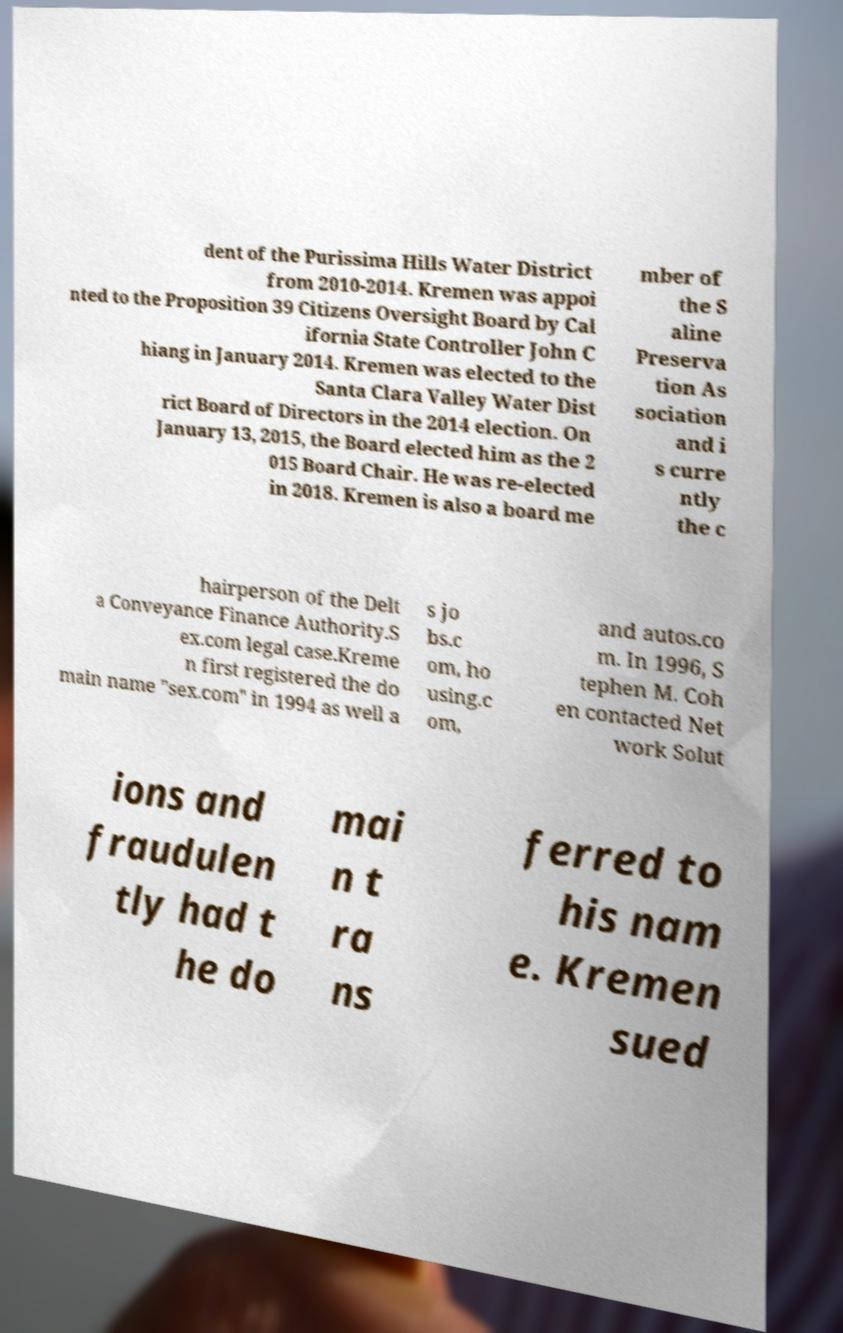There's text embedded in this image that I need extracted. Can you transcribe it verbatim? dent of the Purissima Hills Water District from 2010-2014. Kremen was appoi nted to the Proposition 39 Citizens Oversight Board by Cal ifornia State Controller John C hiang in January 2014. Kremen was elected to the Santa Clara Valley Water Dist rict Board of Directors in the 2014 election. On January 13, 2015, the Board elected him as the 2 015 Board Chair. He was re-elected in 2018. Kremen is also a board me mber of the S aline Preserva tion As sociation and i s curre ntly the c hairperson of the Delt a Conveyance Finance Authority.S ex.com legal case.Kreme n first registered the do main name "sex.com" in 1994 as well a s jo bs.c om, ho using.c om, and autos.co m. In 1996, S tephen M. Coh en contacted Net work Solut ions and fraudulen tly had t he do mai n t ra ns ferred to his nam e. Kremen sued 